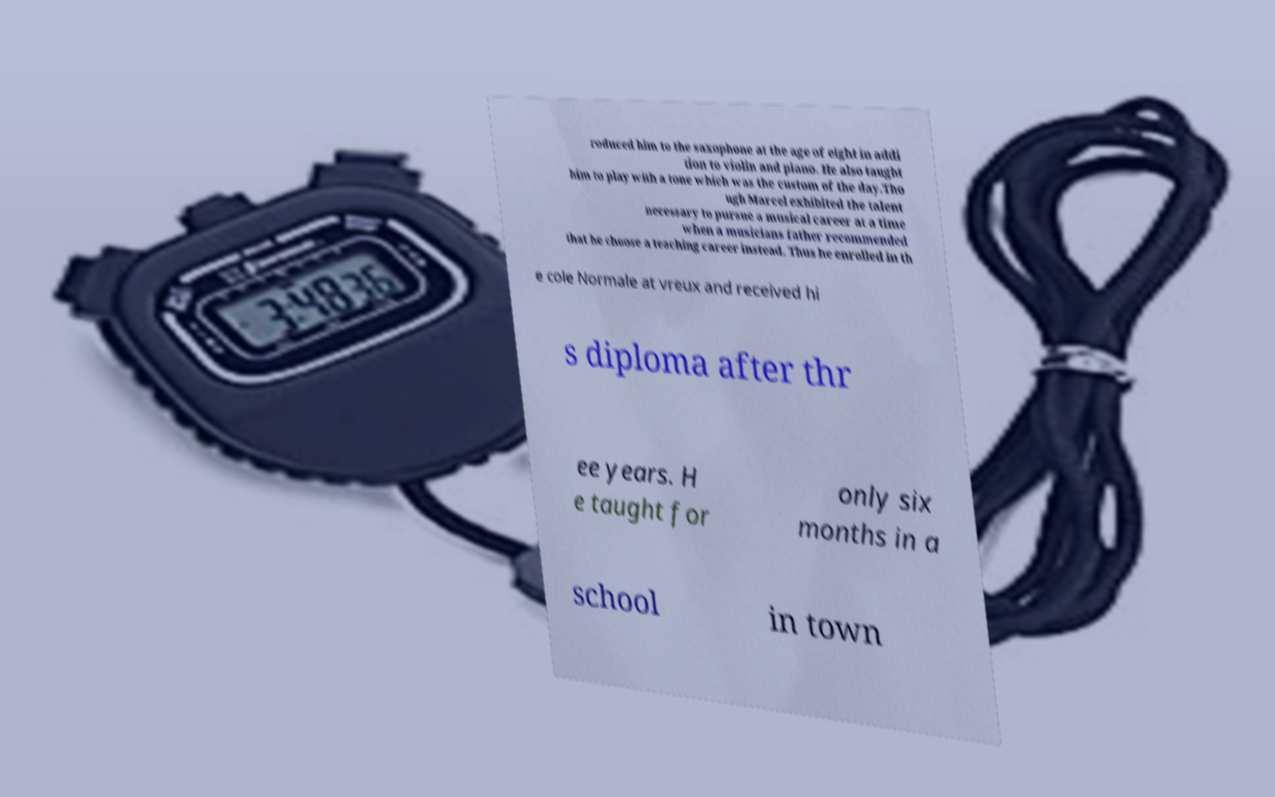Please identify and transcribe the text found in this image. roduced him to the saxophone at the age of eight in addi tion to violin and piano. He also taught him to play with a tone which was the custom of the day.Tho ugh Marcel exhibited the talent necessary to pursue a musical career at a time when a musicians father recommended that he choose a teaching career instead. Thus he enrolled in th e cole Normale at vreux and received hi s diploma after thr ee years. H e taught for only six months in a school in town 